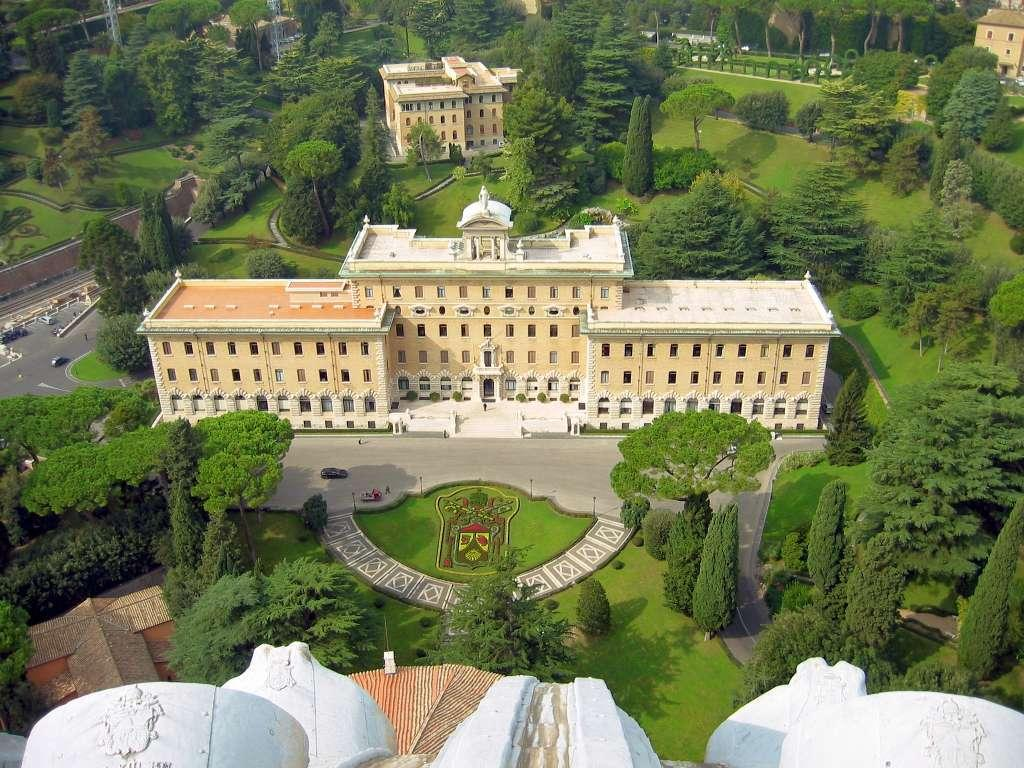What type of view is shown in the image? The image is an aerial view. What structures can be seen in the image? There are buildings in the image. What type of ground is visible in the image? There is a lawn in the image. What type of transportation is visible in the image? Vehicles are moving on the road in the image. What type of vegetation is visible in the image? Trees are visible in the image. Can you see a dog exchanging low-fives with a tree in the image? There is no dog or low-fives in the image; it only shows an aerial view of buildings, a lawn, vehicles, and trees. 